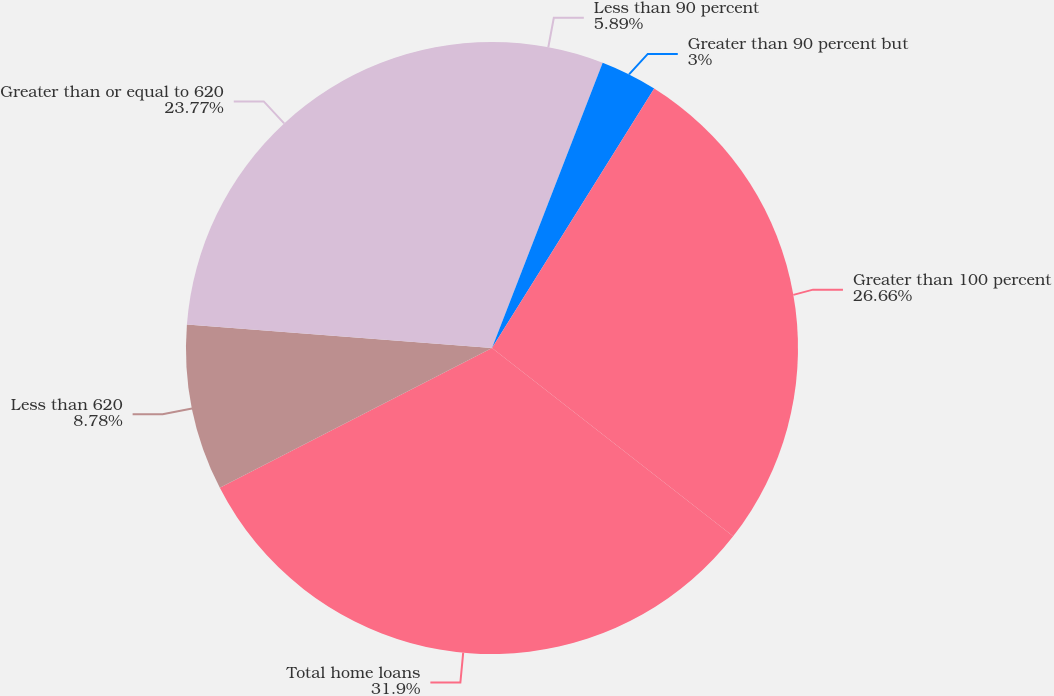Convert chart to OTSL. <chart><loc_0><loc_0><loc_500><loc_500><pie_chart><fcel>Less than 90 percent<fcel>Greater than 90 percent but<fcel>Greater than 100 percent<fcel>Total home loans<fcel>Less than 620<fcel>Greater than or equal to 620<nl><fcel>5.89%<fcel>3.0%<fcel>26.66%<fcel>31.89%<fcel>8.78%<fcel>23.77%<nl></chart> 